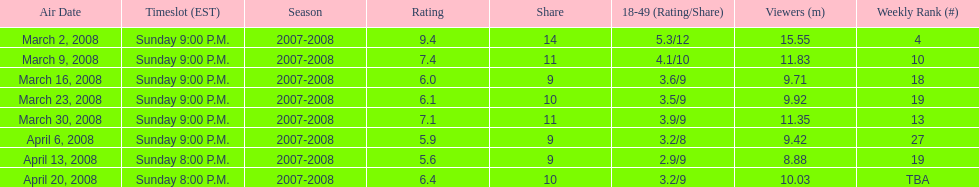Which air date had the least viewers? April 13, 2008. 